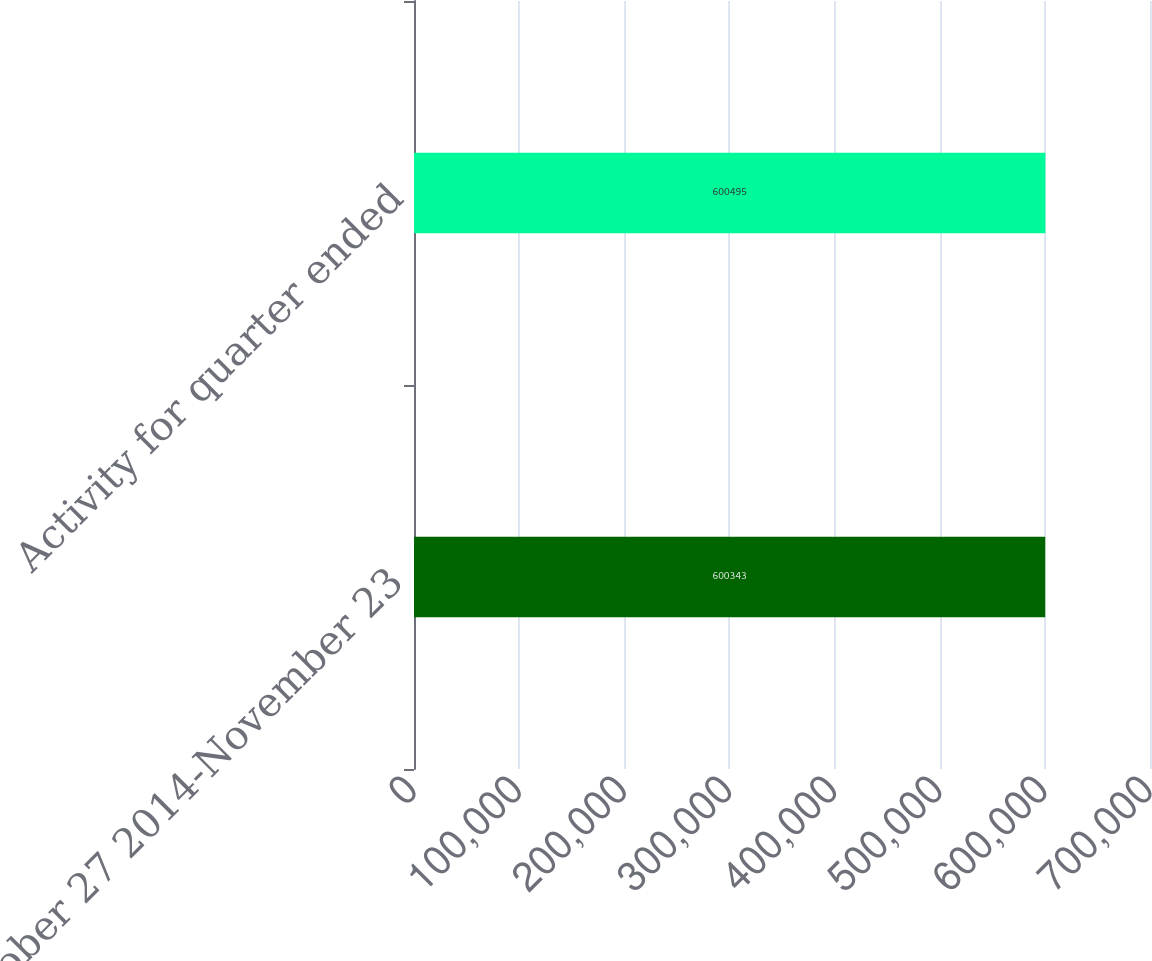<chart> <loc_0><loc_0><loc_500><loc_500><bar_chart><fcel>October 27 2014-November 23<fcel>Activity for quarter ended<nl><fcel>600343<fcel>600495<nl></chart> 